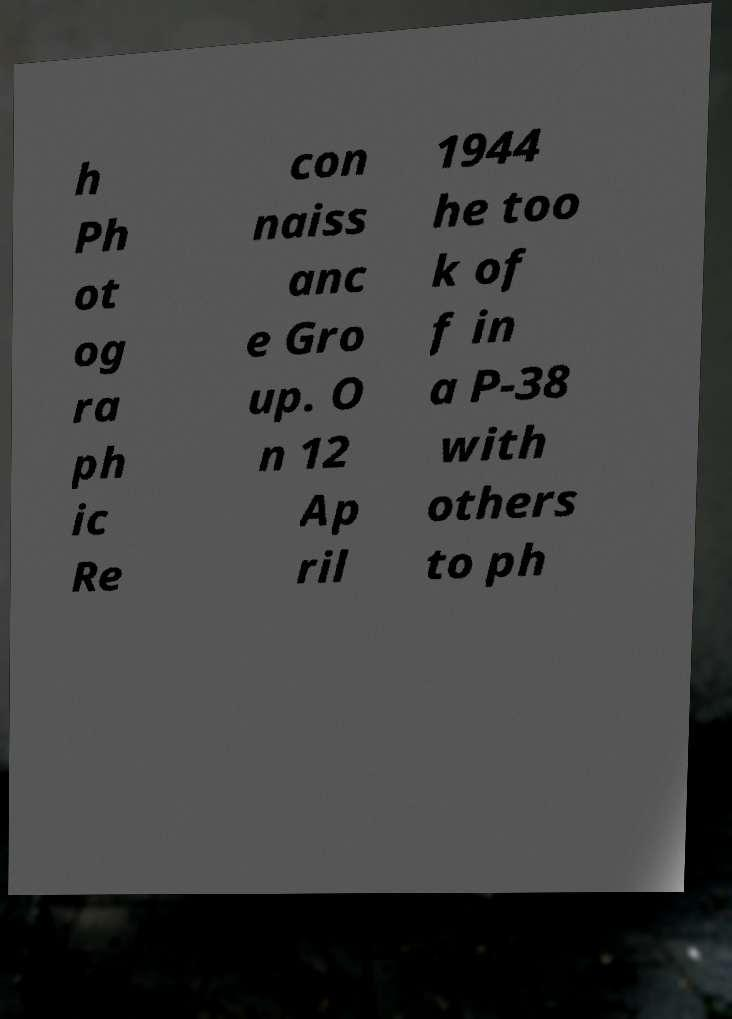Please identify and transcribe the text found in this image. h Ph ot og ra ph ic Re con naiss anc e Gro up. O n 12 Ap ril 1944 he too k of f in a P-38 with others to ph 